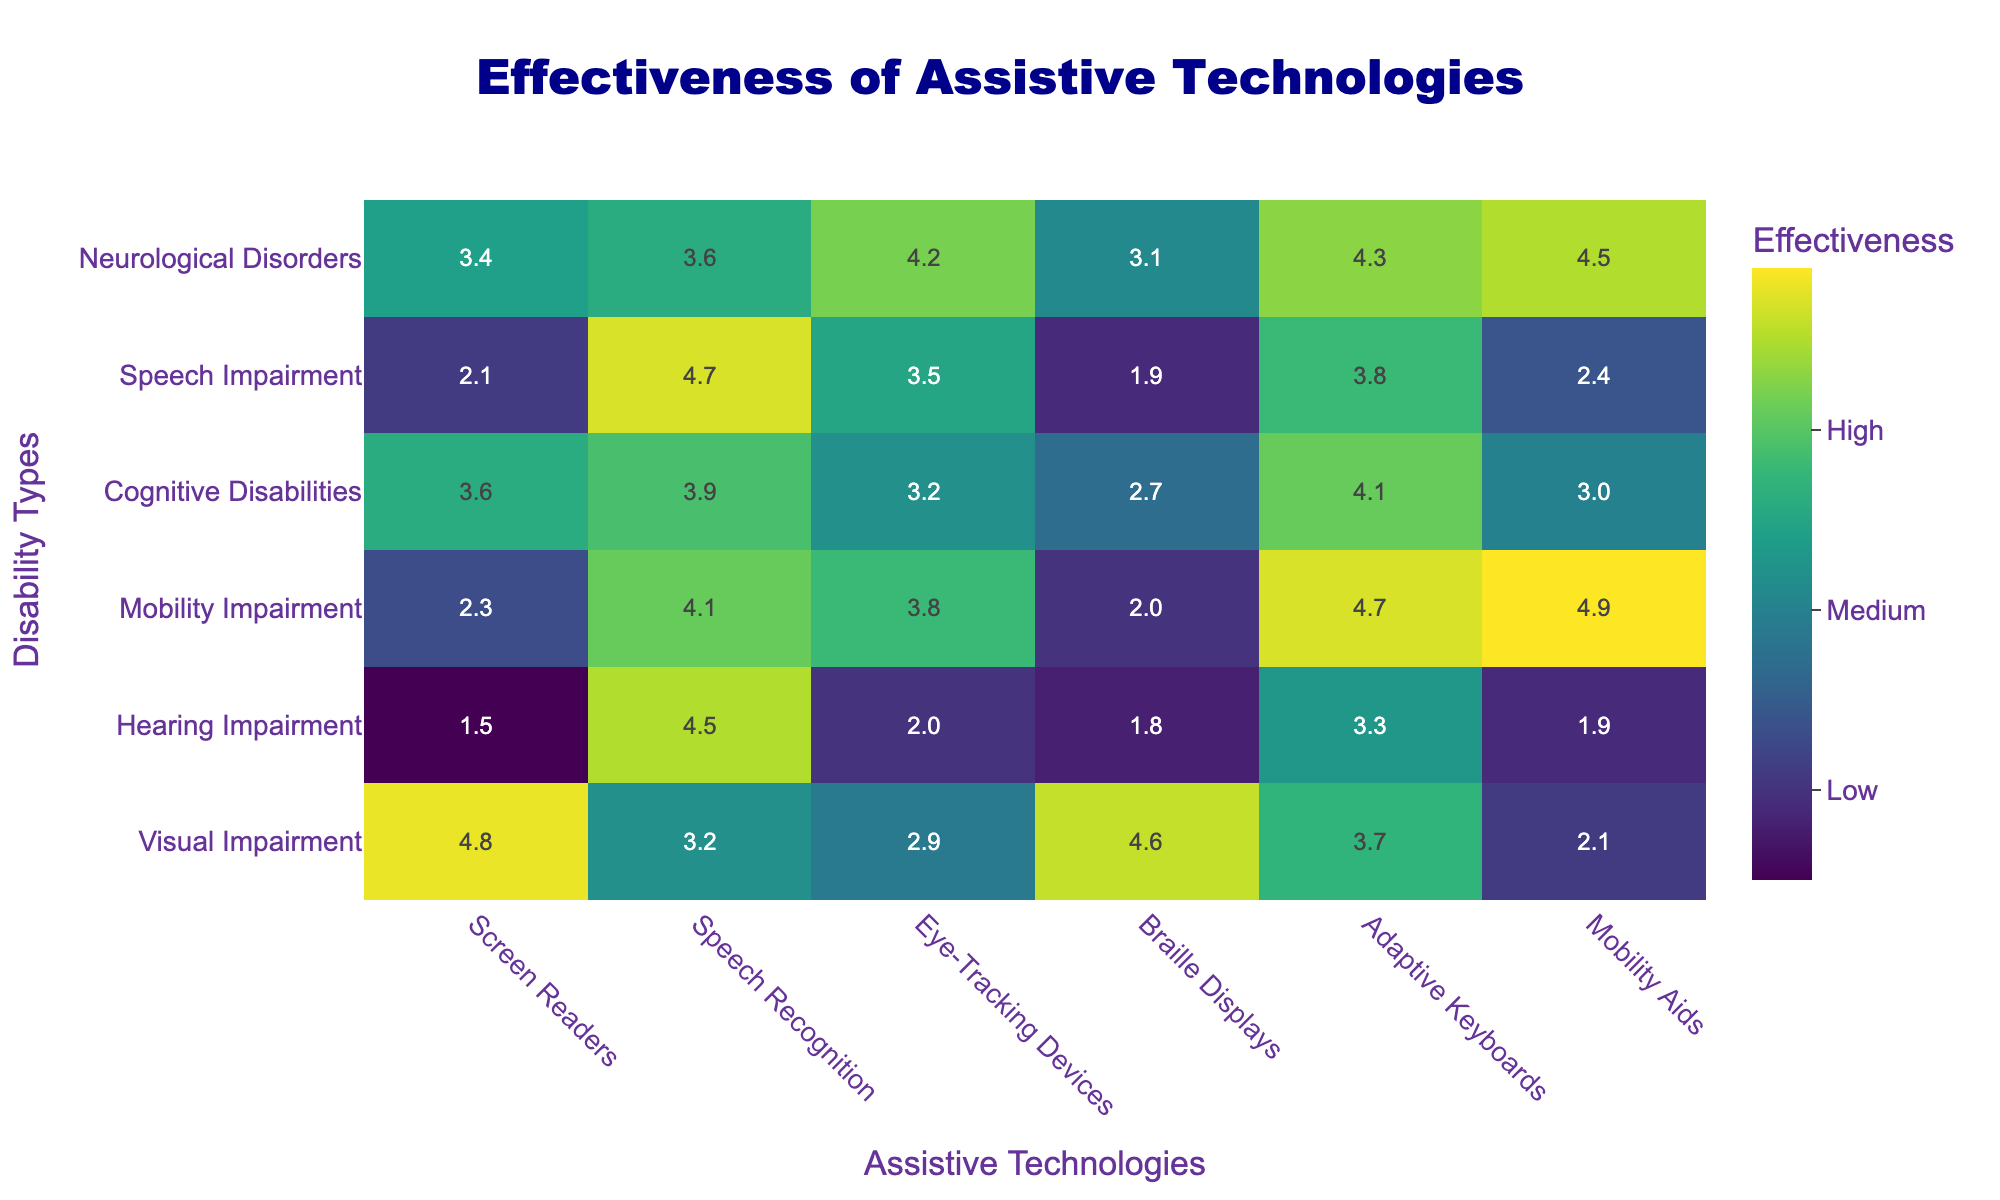What is the effectiveness rating of screen readers for individuals with visual impairment? The effectiveness rating for screen readers in the row corresponding to visual impairment is 4.8, as indicated in the table.
Answer: 4.8 Which assistive technology has the highest effectiveness rating for those with mobility impairment? Looking at the row for mobility impairment, the highest rating is for mobility aids, which has a value of 4.9.
Answer: 4.9 Is there an assistive technology rated as very low (1) effectiveness for hearing impairment? In the hearing impairment row, no technology has a rating of 1, as the lowest rating is 1.5 for screen readers.
Answer: No What is the average effectiveness rating of adaptive keyboards across all disabilities? To find the average, sum the ratings for adaptive keyboards (3.7 + 3.3 + 4.7 + 4.1 + 3.8 + 4.3 = 24.9) and divide by the number of disabilities, which is 6. Thus, 24.9 / 6 = 4.15.
Answer: 4.15 Which technology has a higher effectiveness rating for cognitive disabilities: eye-tracking devices or speech recognition? The row for cognitive disabilities shows that the rating for eye-tracking devices is 3.2 and for speech recognition is 3.9. Since 3.9 is greater than 3.2, speech recognition has a higher rating.
Answer: Speech recognition What is the difference in effectiveness ratings of Braille displays between visual impairment and speech impairment? For visual impairment, the Braille display rating is 4.6, and for speech impairment, it is 1.9. The difference is calculated as 4.6 - 1.9 = 2.7.
Answer: 2.7 Which type of disability has the lowest rating for screen readers? Examining the ratings for screen readers, the lowest score is 1.5 for hearing impairment, which indicates it is the lowest among all disabilities.
Answer: Hearing impairment Among the assistive technologies, which one has the least effectiveness for individuals with neurological disorders? In the row for neurological disorders, the lowest rating is for eye-tracking devices, which has a rating of 4.2 compared to other technologies listed.
Answer: Eye-tracking devices What is the highest effectiveness rating across all categories for speech recognition technology? In the speech recognition column, the highest rating is 4.7, which corresponds to speech impairment in the table.
Answer: 4.7 Which disability type benefits most from mobility aids according to the provided data? The effectiveness rating for mobility aids for mobility impairment is 4.9, the highest rating compared to other disabilities listed in the table.
Answer: Mobility impairment What is the average effectiveness rating for screen readers across all disability types? To calculate the average rating for screen readers, add the ratings: 4.8 + 1.5 + 2.3 + 3.6 + 2.1 + 3.4 = 17.8, then divide by the number of disabilities (6), resulting in 17.8 / 6 = 2.9667 (approximately 3.0).
Answer: 3.0 